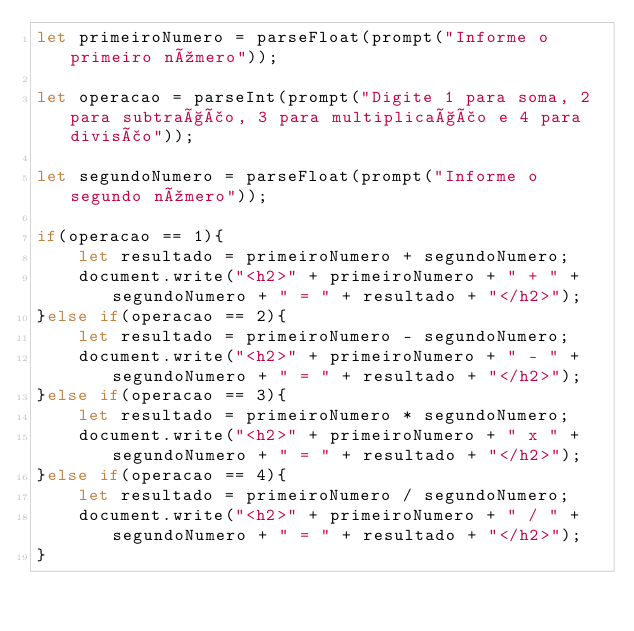Convert code to text. <code><loc_0><loc_0><loc_500><loc_500><_JavaScript_>let primeiroNumero = parseFloat(prompt("Informe o primeiro número"));

let operacao = parseInt(prompt("Digite 1 para soma, 2 para subtração, 3 para multiplicação e 4 para divisão"));

let segundoNumero = parseFloat(prompt("Informe o segundo número"));

if(operacao == 1){
    let resultado = primeiroNumero + segundoNumero;
    document.write("<h2>" + primeiroNumero + " + " + segundoNumero + " = " + resultado + "</h2>");
}else if(operacao == 2){
    let resultado = primeiroNumero - segundoNumero;
    document.write("<h2>" + primeiroNumero + " - " + segundoNumero + " = " + resultado + "</h2>");
}else if(operacao == 3){
    let resultado = primeiroNumero * segundoNumero;
    document.write("<h2>" + primeiroNumero + " x " + segundoNumero + " = " + resultado + "</h2>");
}else if(operacao == 4){
    let resultado = primeiroNumero / segundoNumero;
    document.write("<h2>" + primeiroNumero + " / " + segundoNumero + " = " + resultado + "</h2>");
}


</code> 